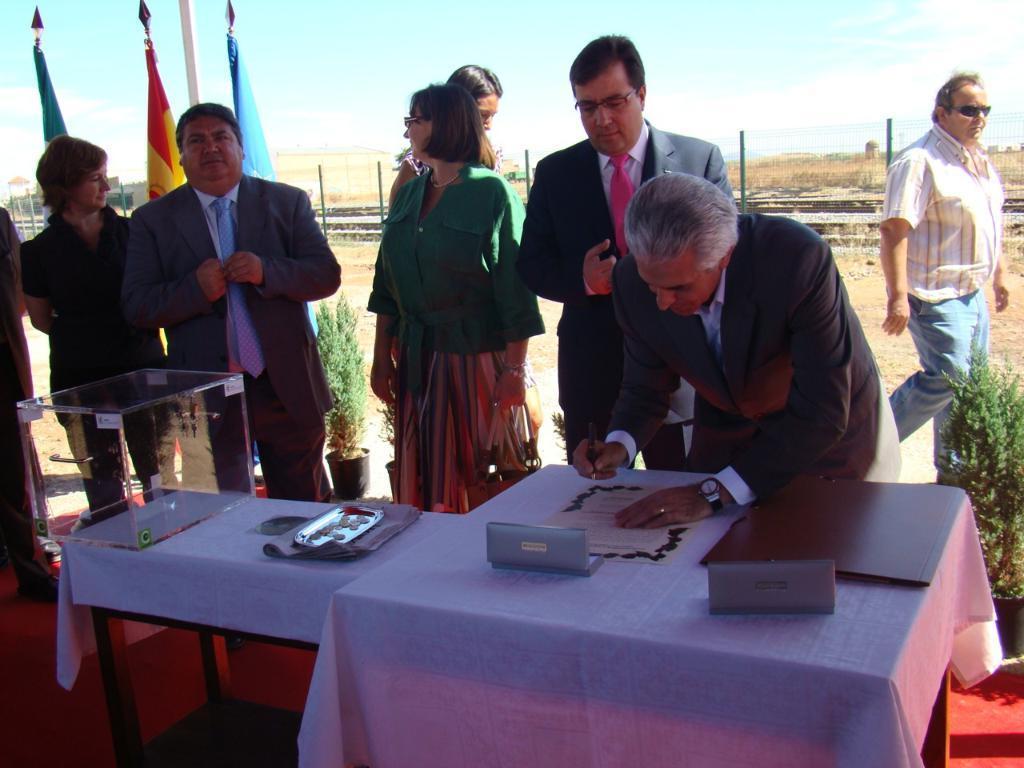Describe this image in one or two sentences. In this image i can see few people standing, on the table i can see a glass box, a file and few papers. In the background i can see three flags and the sky. 